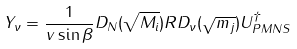<formula> <loc_0><loc_0><loc_500><loc_500>Y _ { \nu } = \frac { 1 } { v \sin \beta } D _ { N } ( \sqrt { M _ { i } } ) R D _ { \nu } ( \sqrt { m _ { j } } ) U ^ { \dagger } _ { P M N S } \\</formula> 